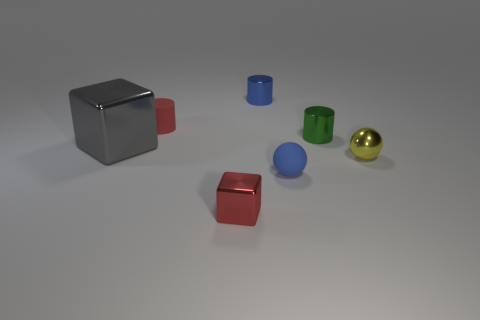Subtract all green cylinders. How many cylinders are left? 2 Subtract all cubes. How many objects are left? 5 Subtract all blue cylinders. How many cylinders are left? 2 Add 1 cyan matte cylinders. How many objects exist? 8 Subtract 0 cyan blocks. How many objects are left? 7 Subtract 2 cylinders. How many cylinders are left? 1 Subtract all green cubes. Subtract all gray spheres. How many cubes are left? 2 Subtract all green balls. How many blue cylinders are left? 1 Subtract all blue shiny objects. Subtract all big gray cubes. How many objects are left? 5 Add 6 red matte things. How many red matte things are left? 7 